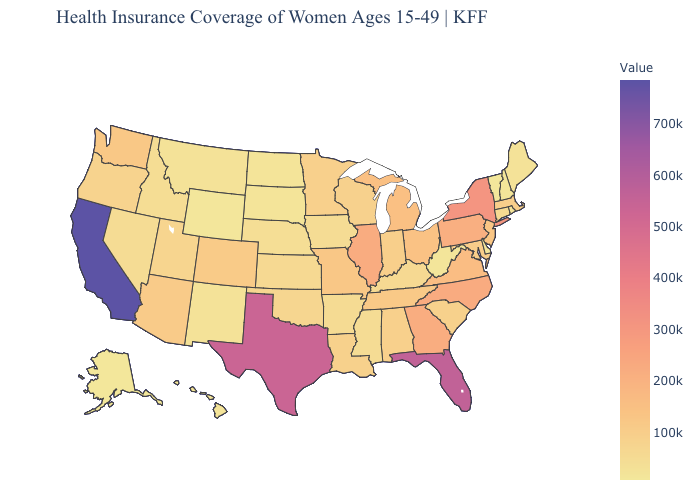Does South Dakota have the lowest value in the MidWest?
Give a very brief answer. Yes. Among the states that border Louisiana , does Arkansas have the highest value?
Concise answer only. No. Among the states that border Louisiana , which have the lowest value?
Concise answer only. Mississippi. Does Washington have a lower value than Hawaii?
Short answer required. No. Does California have the highest value in the USA?
Answer briefly. Yes. 